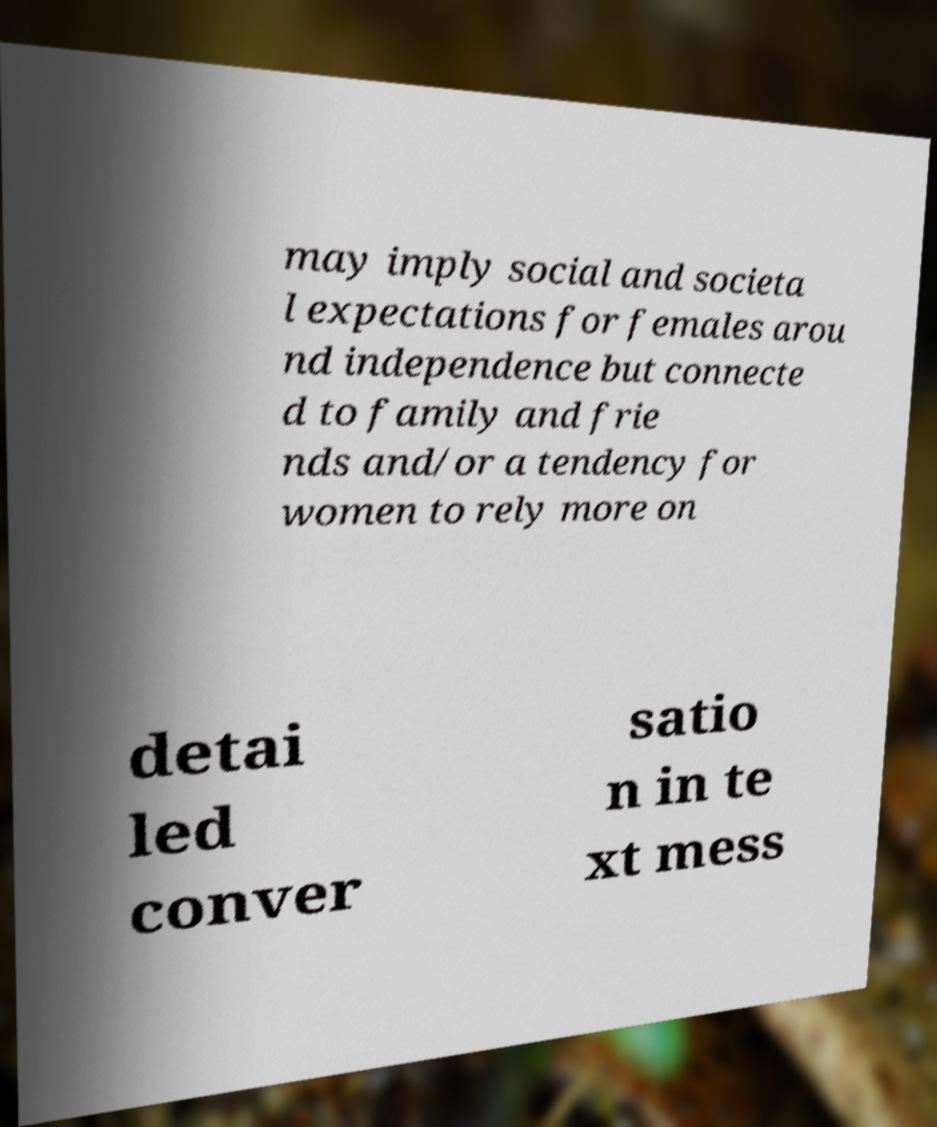Please identify and transcribe the text found in this image. may imply social and societa l expectations for females arou nd independence but connecte d to family and frie nds and/or a tendency for women to rely more on detai led conver satio n in te xt mess 